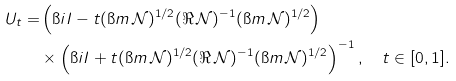Convert formula to latex. <formula><loc_0><loc_0><loc_500><loc_500>U _ { t } = & \left ( \i i I - t ( \i m \, \mathcal { N } ) ^ { 1 / 2 } ( \Re \, \mathcal { N } ) ^ { - 1 } ( \i m \, \mathcal { N } ) ^ { 1 / 2 } \right ) \\ & \times \left ( \i i I + t ( \i m \, \mathcal { N } ) ^ { 1 / 2 } ( \Re \, \mathcal { N } ) ^ { - 1 } ( \i m \, \mathcal { N } ) ^ { 1 / 2 } \right ) ^ { - 1 } , \quad t \in [ 0 , 1 ] .</formula> 